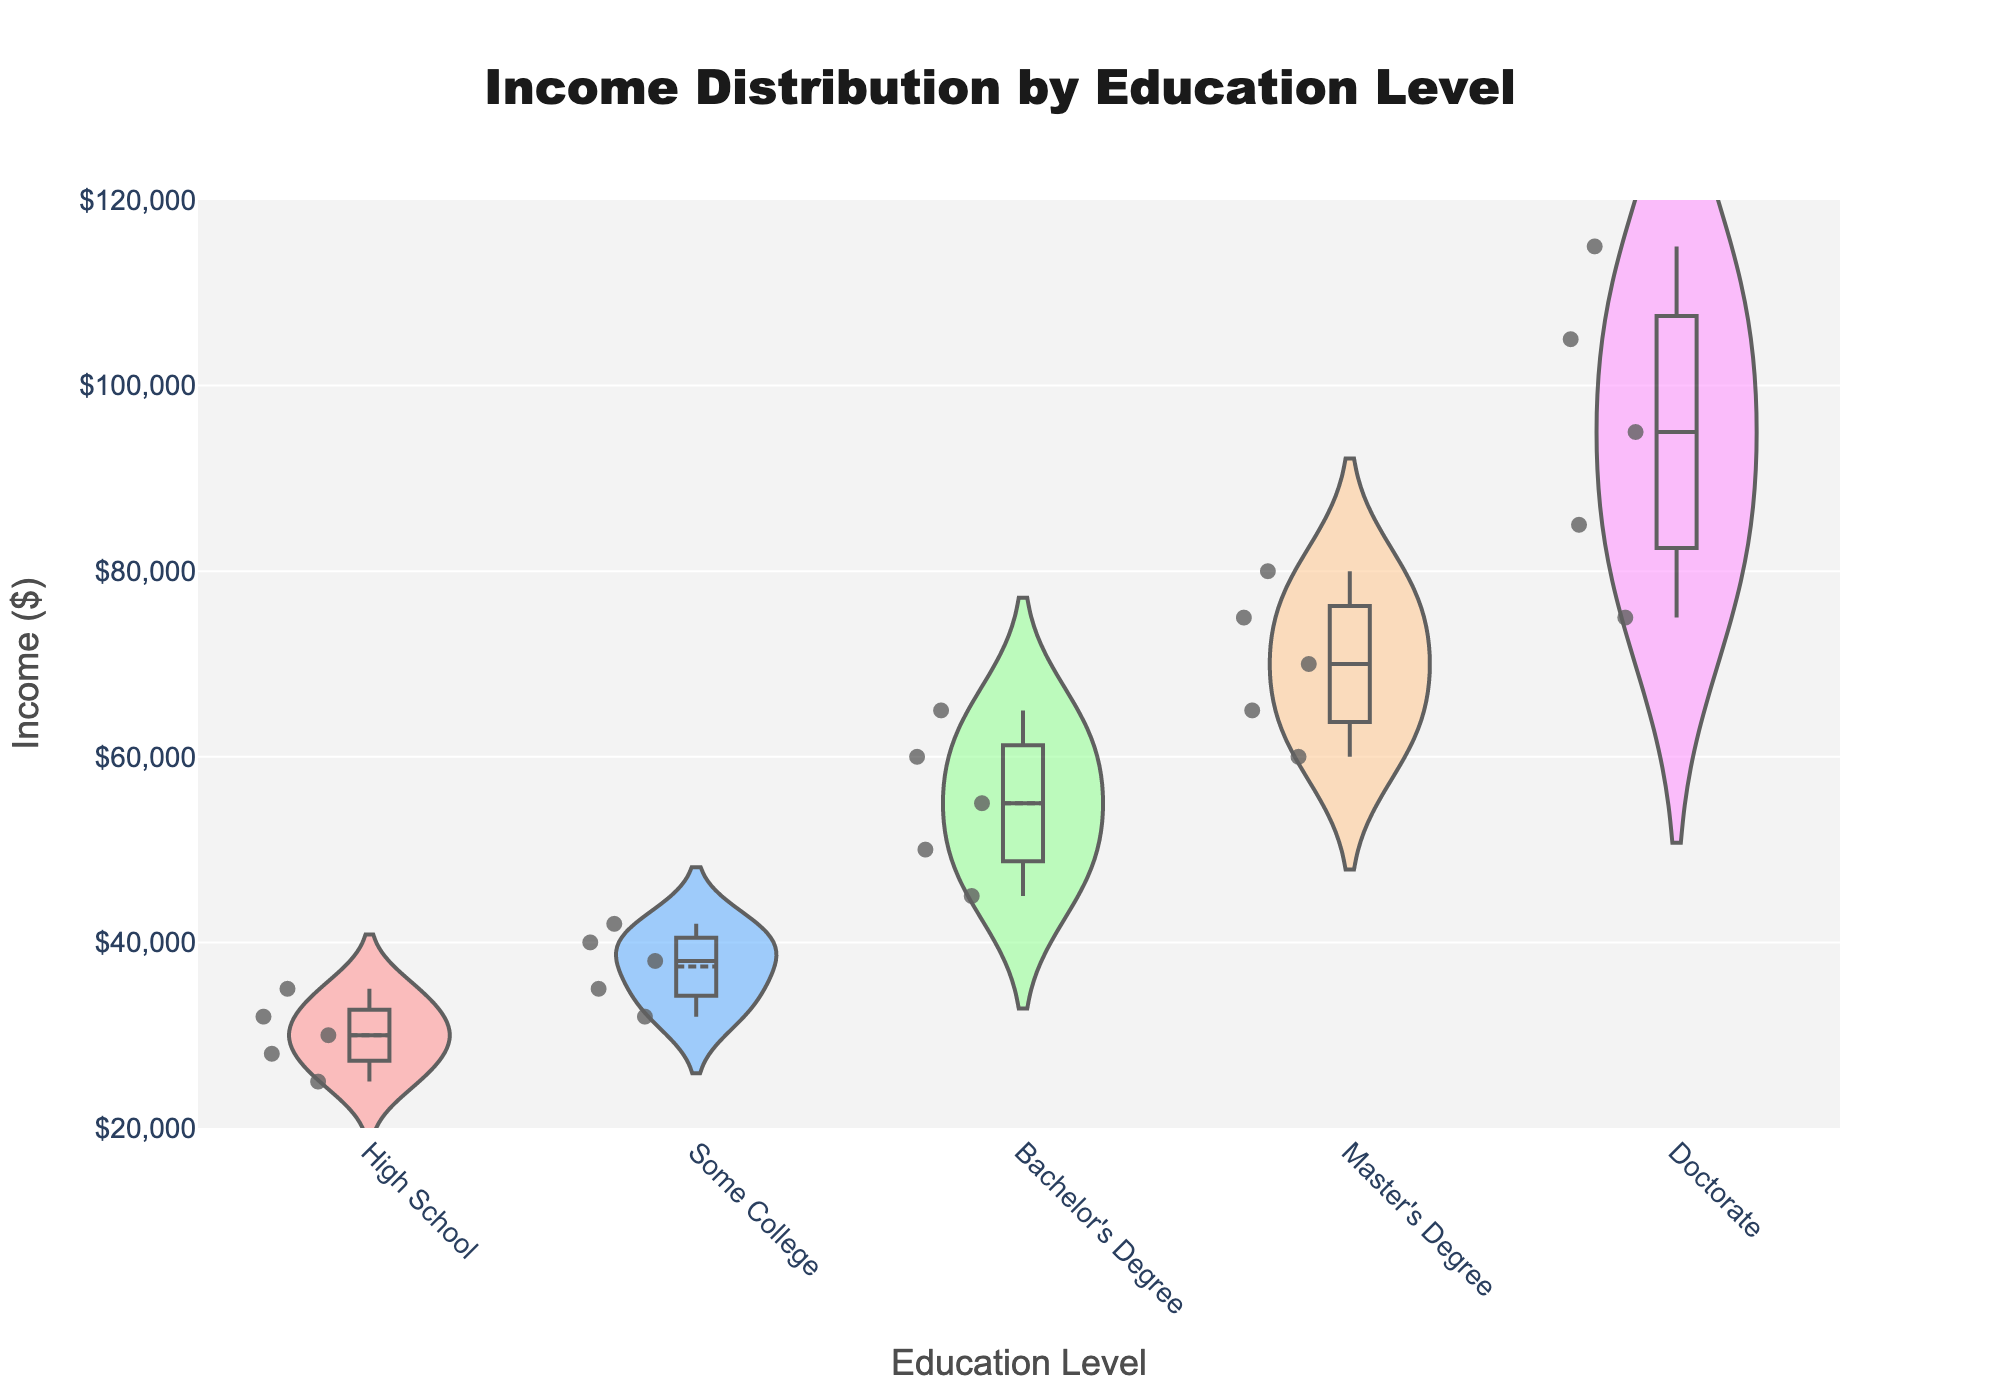What is the title of the figure? The title of the figure is displayed prominently at the top. It reads "Income Distribution by Education Level."
Answer: Income Distribution by Education Level What does the x-axis represent? The label on the x-axis indicates it represents different "Education Levels" such as High School, Some College, Bachelor's Degree, Master's Degree, and Doctorate.
Answer: Education Level What is the lowest income reported in the dataset for any education level? The smallest figure on the y-axis corresponds to income, which starts at $25,000 for the High School level, as observed from the data points on the leftmost side of the figure.
Answer: $25,000 Which education level has the highest income distribution? By observing the vertical span of the violin plots, the Doctorate level shows the highest income distribution, ranging from $75,000 to $115,000.
Answer: Doctorate Which education level has the widest range of incomes? The range of incomes can be assessed by the height of each violin plot. The Doctorate level spans from $75,000 to $115,000, making it the widest range.
Answer: Doctorate What is the median income for individuals with a Bachelor's Degree? The thin black line in the center of the Bachelor's Degree violin plot represents the median income. It is at $55,000.
Answer: $55,000 How does the income distribution for those with a Master’s Degree compare to those with a Bachelor’s Degree? Both education levels have overlapping income ranges, but individuals with a Master's Degree tend to have higher incomes, with the range starting where the Bachelor's Degree range ends. This suggests that higher education correlates with higher income.
Answer: Master's Degree has higher incomes What color represents "Some College"? The color legend or the color surrounding the violin plot for "Some College" is sky blue.
Answer: Sky blue How does the income distribution of those with "Some College" compare to those with "High School"? By comparing the plots, "Some College" has both a higher median income and a slightly wider distribution than "High School." The median for "Some College" hovers around $38,000, while for "High School," it is around $30,000.
Answer: "Some College" has higher and wider Is the mean income of individuals with a Master's Degree higher than those with a Bachelor's Degree? The mean income is shown by the thick horizontal line within each plot. The mean for Master’s Degree is at $70,000, whereas for a Bachelor's Degree it is at $55,000. So yes, the mean is higher for a Master's Degree.
Answer: Yes 